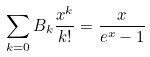<formula> <loc_0><loc_0><loc_500><loc_500>\sum _ { k = 0 } B _ { k } \frac { x ^ { k } } { k ! } = \frac { x } { e ^ { x } - 1 }</formula> 